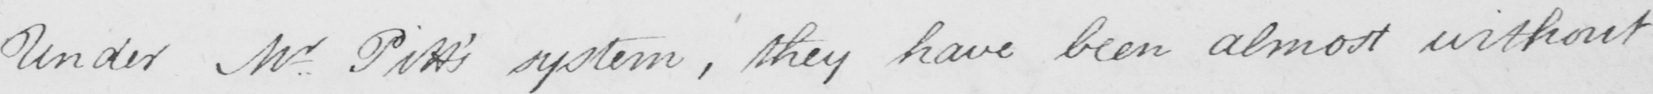What does this handwritten line say? Under Mr Pitt ' s system , they have been almost without 